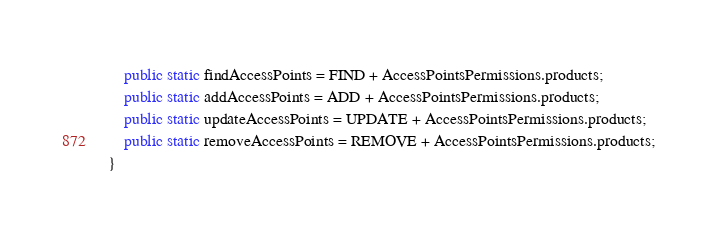<code> <loc_0><loc_0><loc_500><loc_500><_TypeScript_>    public static findAccessPoints = FIND + AccessPointsPermissions.products;
    public static addAccessPoints = ADD + AccessPointsPermissions.products;
    public static updateAccessPoints = UPDATE + AccessPointsPermissions.products;
    public static removeAccessPoints = REMOVE + AccessPointsPermissions.products;
}</code> 